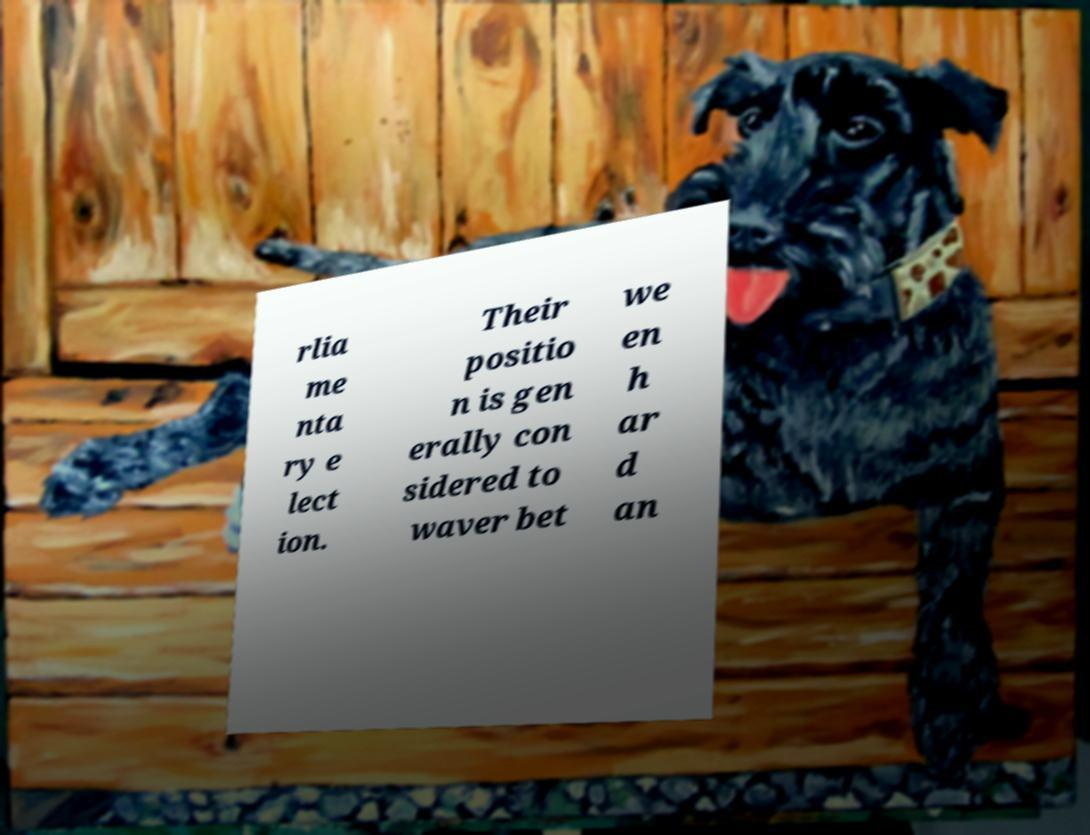Can you accurately transcribe the text from the provided image for me? rlia me nta ry e lect ion. Their positio n is gen erally con sidered to waver bet we en h ar d an 